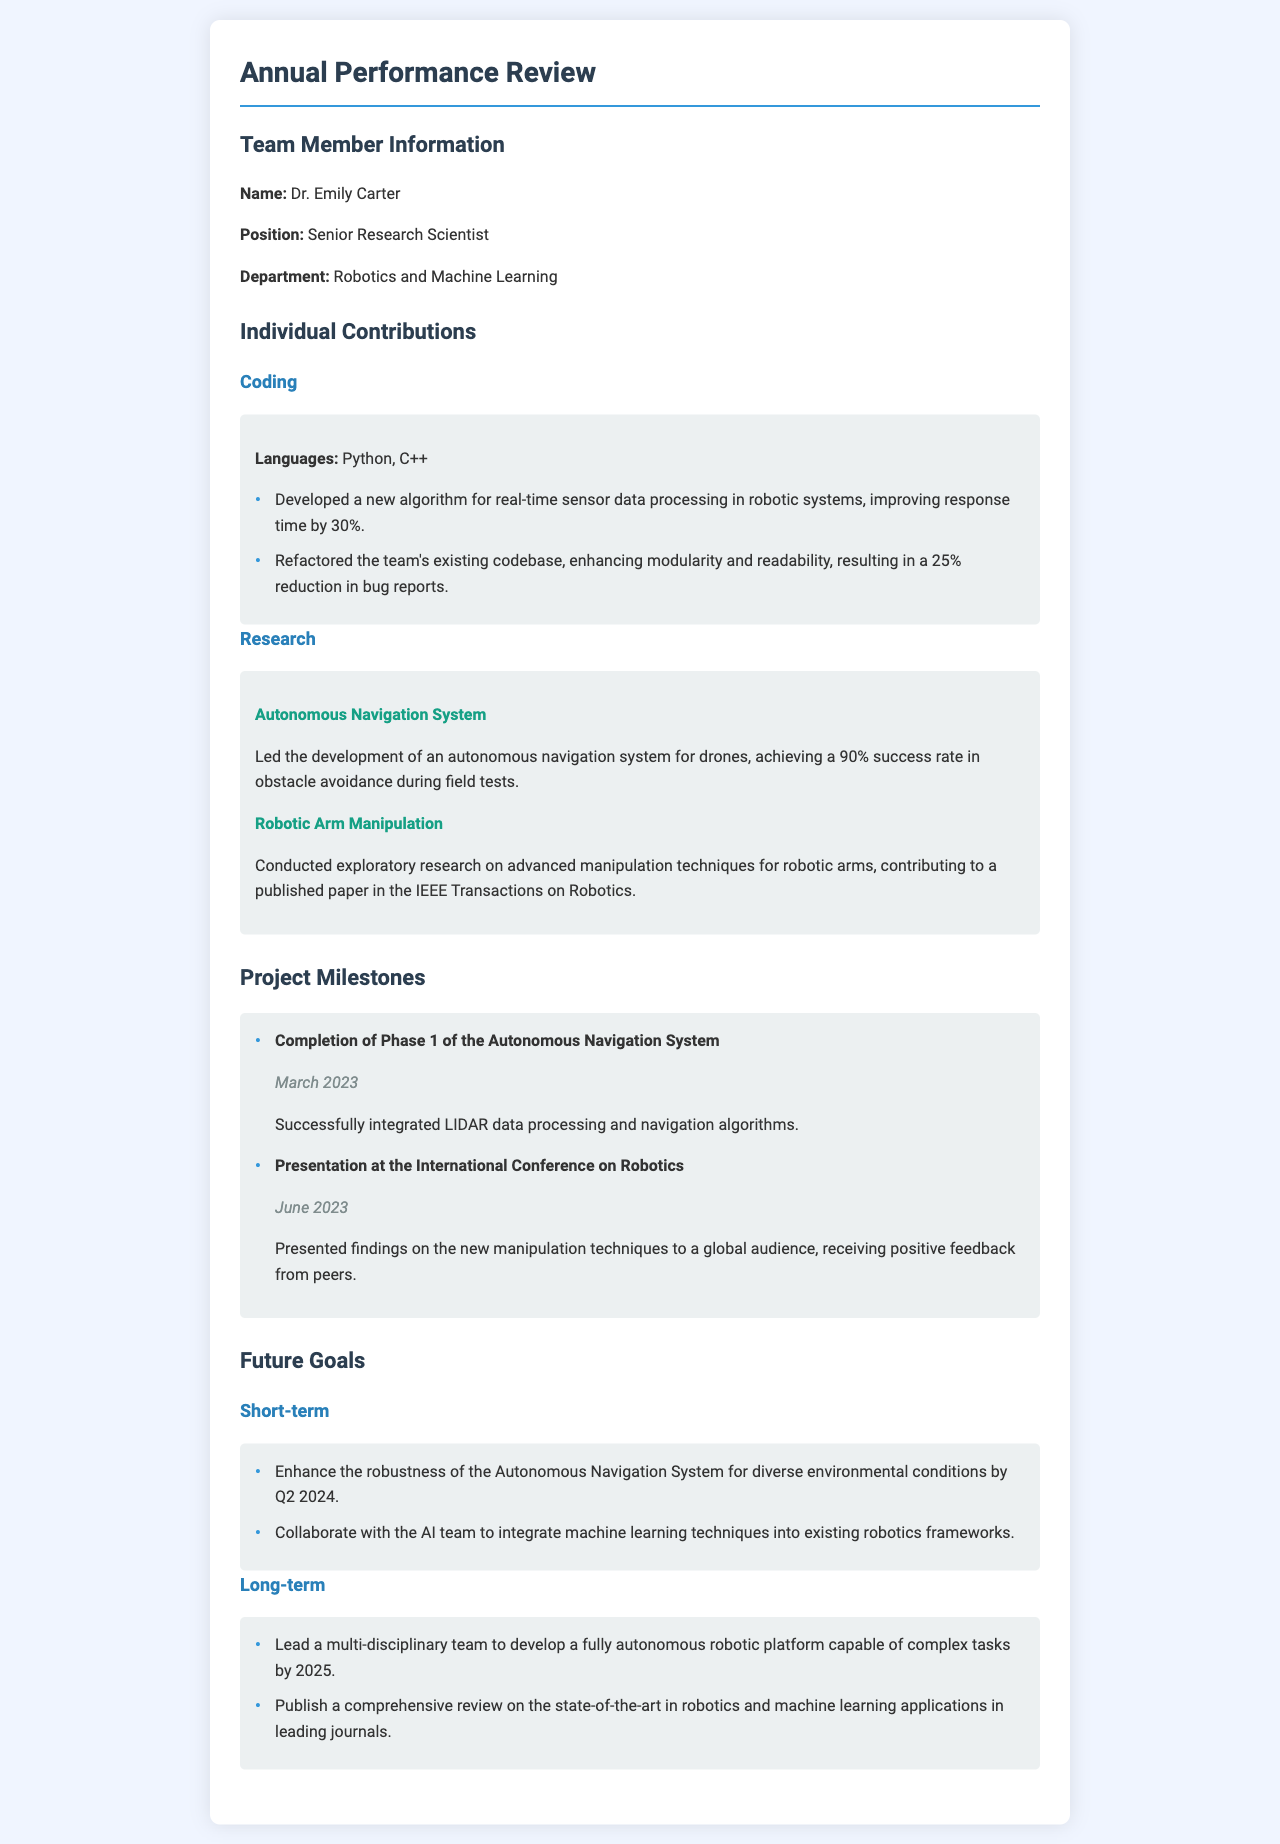What is the name of the team member? The document provides the team member's name in the section titled "Team Member Information."
Answer: Dr. Emily Carter What is the position of Dr. Emily Carter? The position is specified under "Team Member Information" in the document.
Answer: Senior Research Scientist Which programming languages did Dr. Emily Carter use? The languages used are listed under "Individual Contributions" in the Coding section.
Answer: Python, C++ What project achieved a 90% success rate in obstacle avoidance? The project title along with its achievement is mentioned under "Individual Contributions" in the Research section.
Answer: Autonomous Navigation System When was the completion of Phase 1 of the Autonomous Navigation System? The completion date is provided with the milestone in the "Project Milestones" section.
Answer: March 2023 What is one of the short-term goals for Dr. Emily Carter? The goals are listed under "Future Goals," specifically in the Short-term section.
Answer: Enhance the robustness of the Autonomous Navigation System In what year does Dr. Emily Carter aim to lead the development of a fully autonomous robotic platform? The target year is indicated in the Long-term goals section of the document.
Answer: 2025 Which publication did Dr. Emily Carter contribute to regarding robotic arm manipulation? The relevant section lists the involvement in a specific publication under "Individual Contributions."
Answer: IEEE Transactions on Robotics What feedback was received upon Dr. Emily Carter's presentation at the International Conference on Robotics? The feedback is mentioned in relation to the presentation details under "Project Milestones."
Answer: Positive feedback from peers 